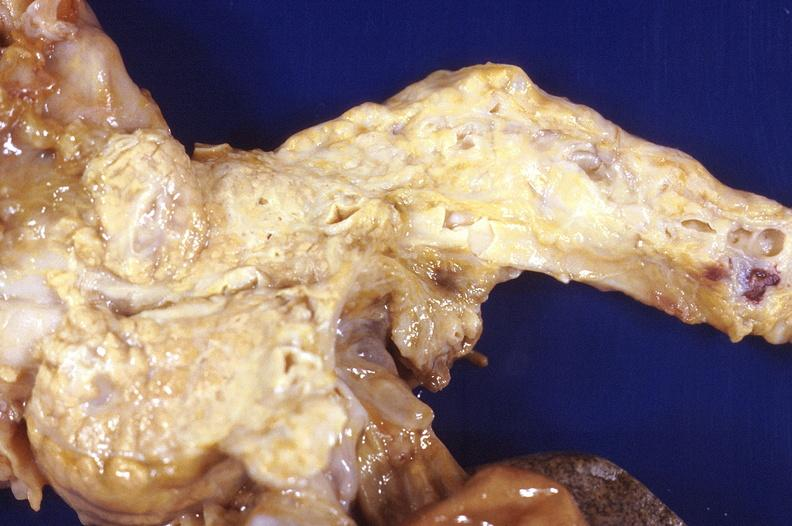where is this?
Answer the question using a single word or phrase. Urinary 